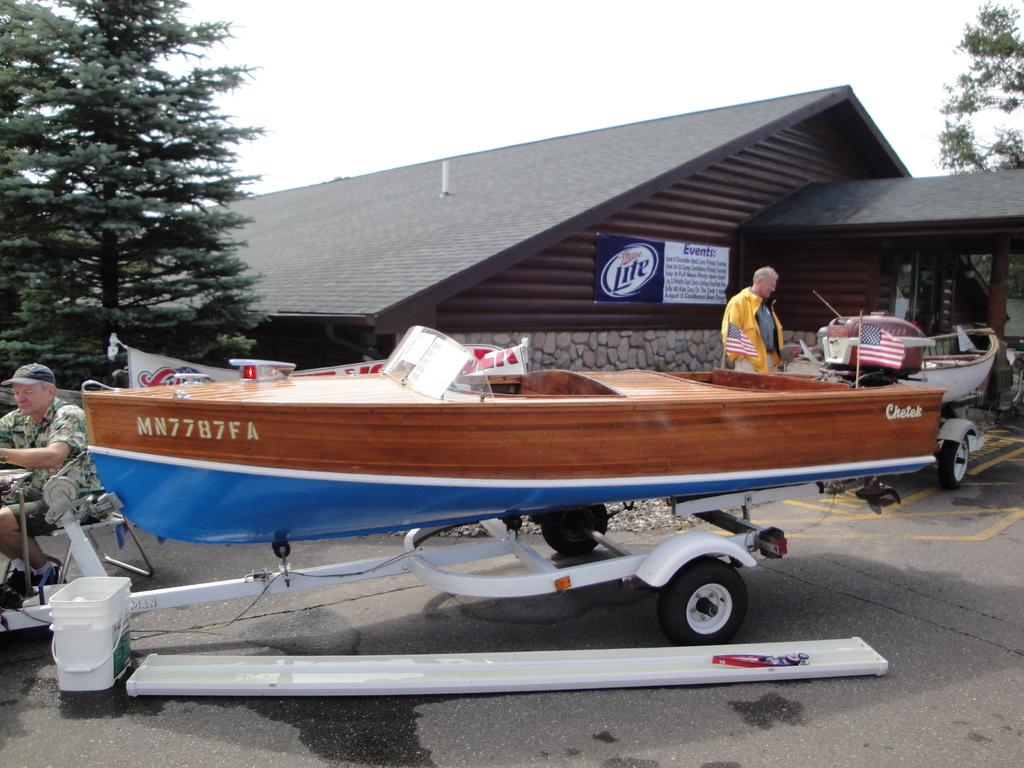Provide a one-sentence caption for the provided image. a Cheteck motor boat outside a wood lodge. 